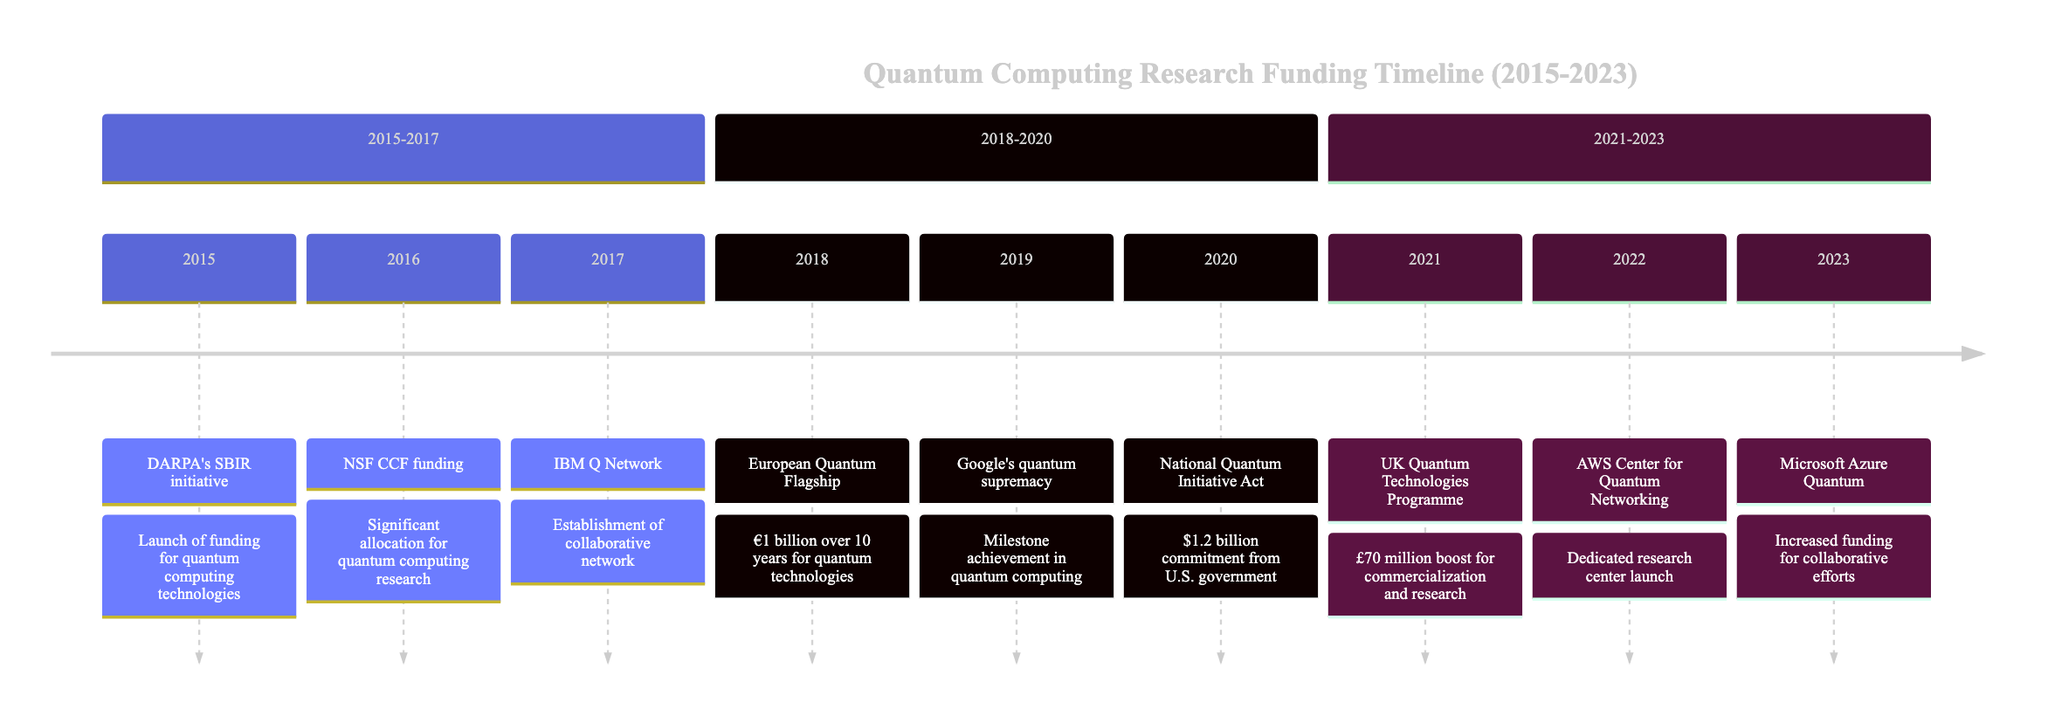What event was introduced in 2015? The diagram labels the event for 2015 as "DARPA's SBIR initiative" indicating this was the new initiative launched that year.
Answer: DARPA's SBIR initiative How much funding did the European Quantum Flagship dedicate in 2018? The diagram states the European Quantum Flagship allocated €1 billion over the course of ten years, clearly stating the amount in the description.
Answer: €1 billion What milestone did Google achieve in 2019? The diagram depicts that Google claimed to have achieved "quantum supremacy" in 2019, clearly identifying the significant milestone reached that year.
Answer: quantum supremacy Which country increased its funding for quantum technologies in 2021? Referring to the UK National Quantum Technologies Programme noted in the 2021 entry, the diagram indicates the UK government as the one that increased funding.
Answer: UK What was a major U.S. funding initiative passed in 2020? The diagram details that in 2020, the "National Quantum Initiative Act" was enacted, marking a significant funding commitment from the U.S. government for quantum research.
Answer: National Quantum Initiative Act Which company launched a Center for Quantum Networking in 2022? The timeline expressly shows that AWS launched the "AWS Center for Quantum Networking" indicating the company behind the center in 2022.
Answer: AWS What is the total investment by the U.S. government as mentioned in 2020? From the diagram, the U.S. government is recorded to have committed over "$1.2 billion" for research and development in quantum information science.
Answer: $1.2 billion What was the amount added to the UK Quantum Technologies Programme in 2021? The diagram highlights that an additional "£70 million" was allocated for commercialization and research under the UK's Quantum Technologies Programme in 2021.
Answer: £70 million What is the focus of the IBM Q Network established in 2017? The description in the diagram states that the IBM Q Network was aimed at fostering collaboration, specifically with "academic institutions, research labs, and businesses" to help advance quantum computing.
Answer: collaboration 